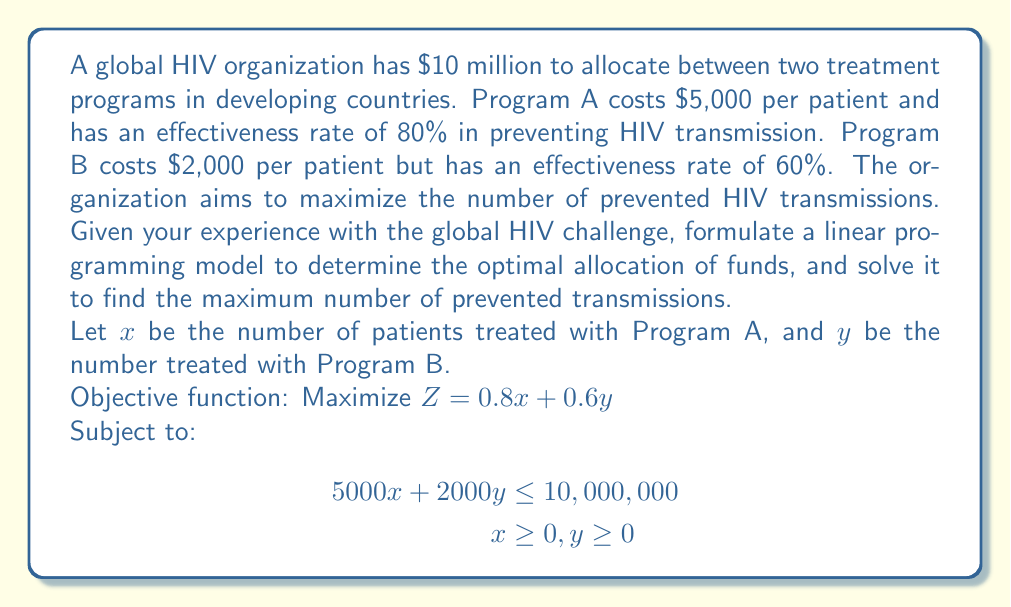What is the answer to this math problem? To solve this linear programming problem, we'll use the graphical method:

1. Plot the constraint:
   $5000x + 2000y = 10,000,000$
   This gives us the line passing through points (2000, 0) and (0, 5000)

2. The feasible region is the area below this line in the first quadrant.

3. The objective function can be written as:
   $Z = 0.8x + 0.6y = k$ (where k is a constant)

4. We need to find the point in the feasible region that gives the maximum value of Z.

5. Plot several lines of the objective function:
   $0.8x + 0.6y = 1000$
   $0.8x + 0.6y = 2000$
   $0.8x + 0.6y = 3000$

6. The optimal solution will be at the corner point of the feasible region that intersects with the highest possible objective function line.

7. The corner points are (0, 5000) and (2000, 0).

8. Evaluate Z at these points:
   At (0, 5000): $Z = 0.8(0) + 0.6(5000) = 3000$
   At (2000, 0): $Z = 0.8(2000) + 0.6(0) = 1600$

9. The maximum value of Z occurs at (0, 5000).

Therefore, the optimal solution is to allocate all funds to Program B, treating 5000 patients and preventing 3000 HIV transmissions.
Answer: The optimal allocation is to use all $10 million on Program B, treating 5000 patients and preventing an estimated 3000 HIV transmissions. 